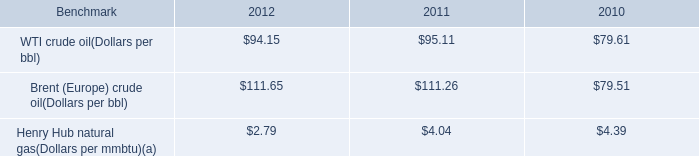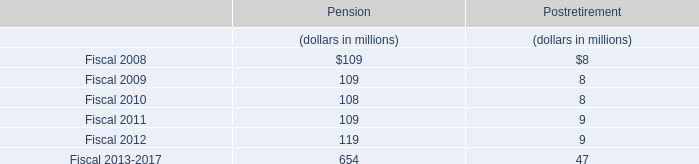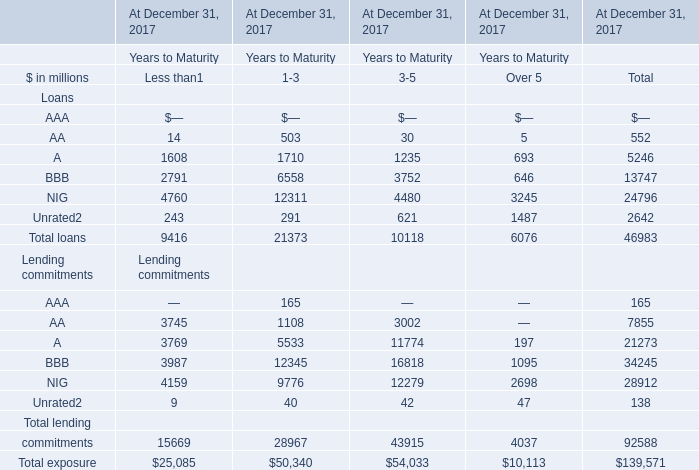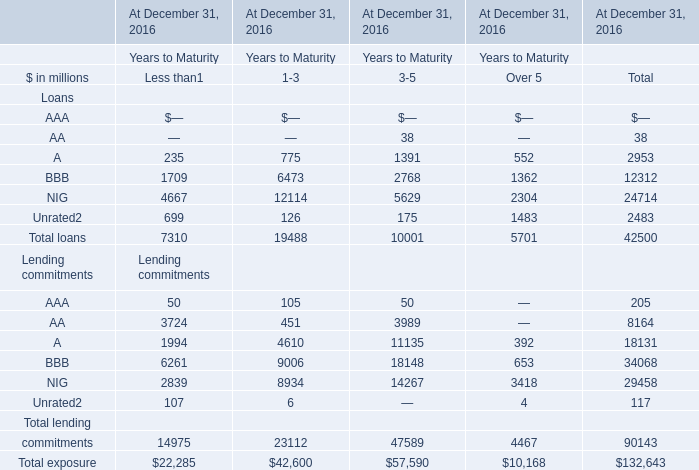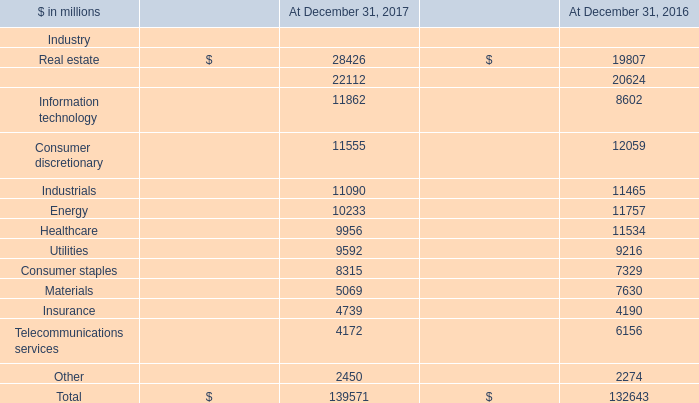What is the sum of BBB Loans of At December 31, 2016 Years to Maturity.1, Healthcare of At December 31, 2017, and Total loans Loans of At December 31, 2016 Years to Maturity.3 ? 
Computations: ((9006.0 + 9956.0) + 5701.0)
Answer: 24663.0. 